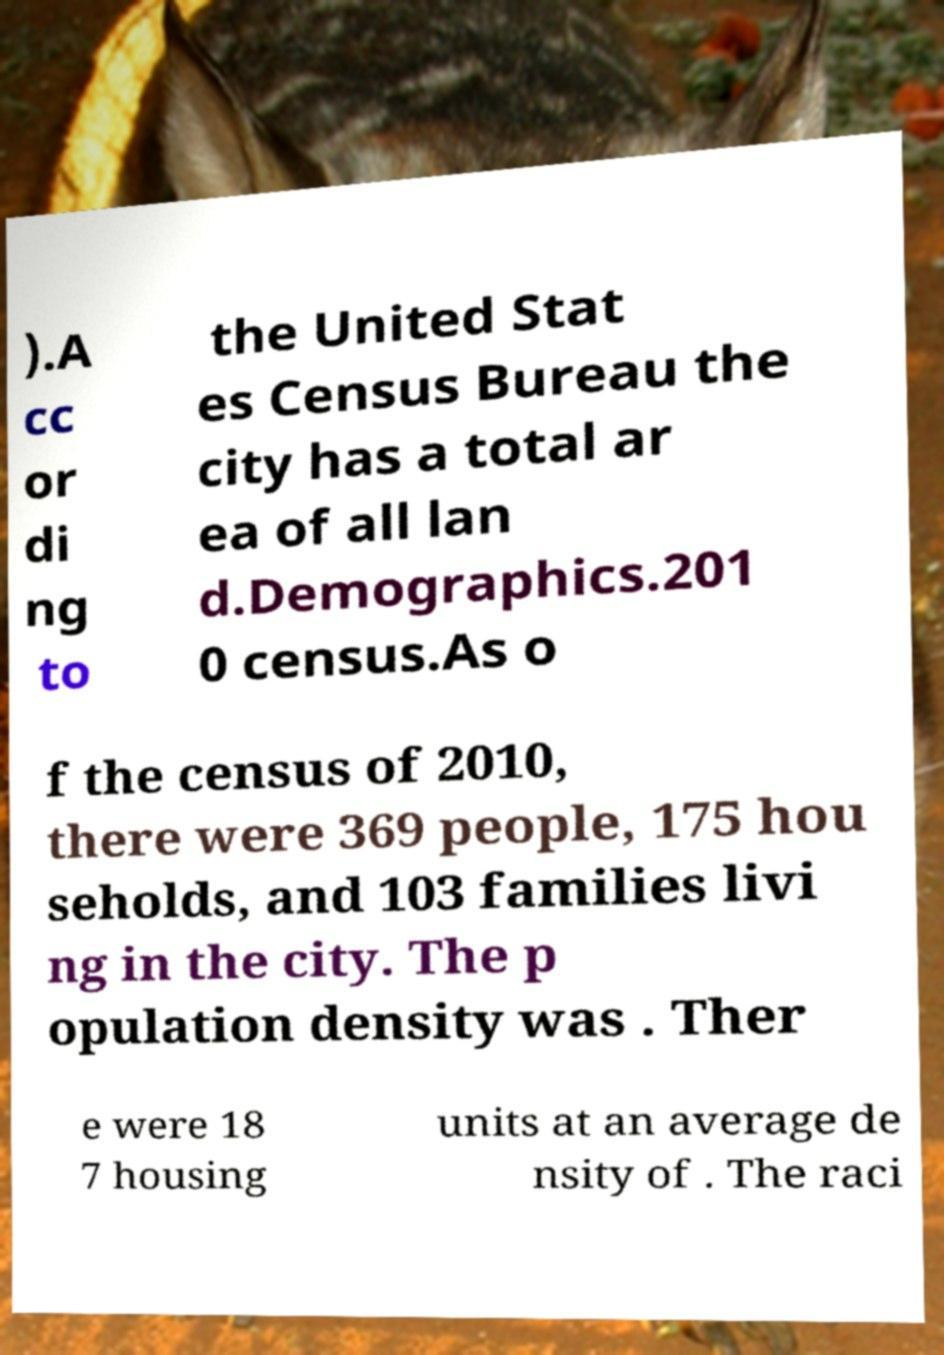There's text embedded in this image that I need extracted. Can you transcribe it verbatim? ).A cc or di ng to the United Stat es Census Bureau the city has a total ar ea of all lan d.Demographics.201 0 census.As o f the census of 2010, there were 369 people, 175 hou seholds, and 103 families livi ng in the city. The p opulation density was . Ther e were 18 7 housing units at an average de nsity of . The raci 